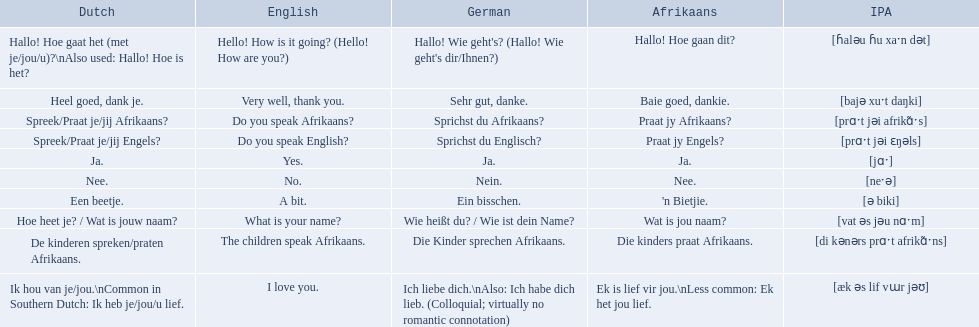Could you parse the entire table as a dict? {'header': ['Dutch', 'English', 'German', 'Afrikaans', 'IPA'], 'rows': [['Hallo! Hoe gaat het (met je/jou/u)?\\nAlso used: Hallo! Hoe is het?', 'Hello! How is it going? (Hello! How are you?)', "Hallo! Wie geht's? (Hallo! Wie geht's dir/Ihnen?)", 'Hallo! Hoe gaan dit?', '[ɦaləu ɦu xaˑn dət]'], ['Heel goed, dank je.', 'Very well, thank you.', 'Sehr gut, danke.', 'Baie goed, dankie.', '[bajə xuˑt daŋki]'], ['Spreek/Praat je/jij Afrikaans?', 'Do you speak Afrikaans?', 'Sprichst du Afrikaans?', 'Praat jy Afrikaans?', '[prɑˑt jəi afrikɑ̃ˑs]'], ['Spreek/Praat je/jij Engels?', 'Do you speak English?', 'Sprichst du Englisch?', 'Praat jy Engels?', '[prɑˑt jəi ɛŋəls]'], ['Ja.', 'Yes.', 'Ja.', 'Ja.', '[jɑˑ]'], ['Nee.', 'No.', 'Nein.', 'Nee.', '[neˑə]'], ['Een beetje.', 'A bit.', 'Ein bisschen.', "'n Bietjie.", '[ə biki]'], ['Hoe heet je? / Wat is jouw naam?', 'What is your name?', 'Wie heißt du? / Wie ist dein Name?', 'Wat is jou naam?', '[vat əs jəu nɑˑm]'], ['De kinderen spreken/praten Afrikaans.', 'The children speak Afrikaans.', 'Die Kinder sprechen Afrikaans.', 'Die kinders praat Afrikaans.', '[di kənərs prɑˑt afrikɑ̃ˑns]'], ['Ik hou van je/jou.\\nCommon in Southern Dutch: Ik heb je/jou/u lief.', 'I love you.', 'Ich liebe dich.\\nAlso: Ich habe dich lieb. (Colloquial; virtually no romantic connotation)', 'Ek is lief vir jou.\\nLess common: Ek het jou lief.', '[æk əs lif vɯr jəʊ]']]} What are the afrikaans phrases? Hallo! Hoe gaan dit?, Baie goed, dankie., Praat jy Afrikaans?, Praat jy Engels?, Ja., Nee., 'n Bietjie., Wat is jou naam?, Die kinders praat Afrikaans., Ek is lief vir jou.\nLess common: Ek het jou lief. For die kinders praat afrikaans, what are the translations? De kinderen spreken/praten Afrikaans., The children speak Afrikaans., Die Kinder sprechen Afrikaans. Which one is the german translation? Die Kinder sprechen Afrikaans. 